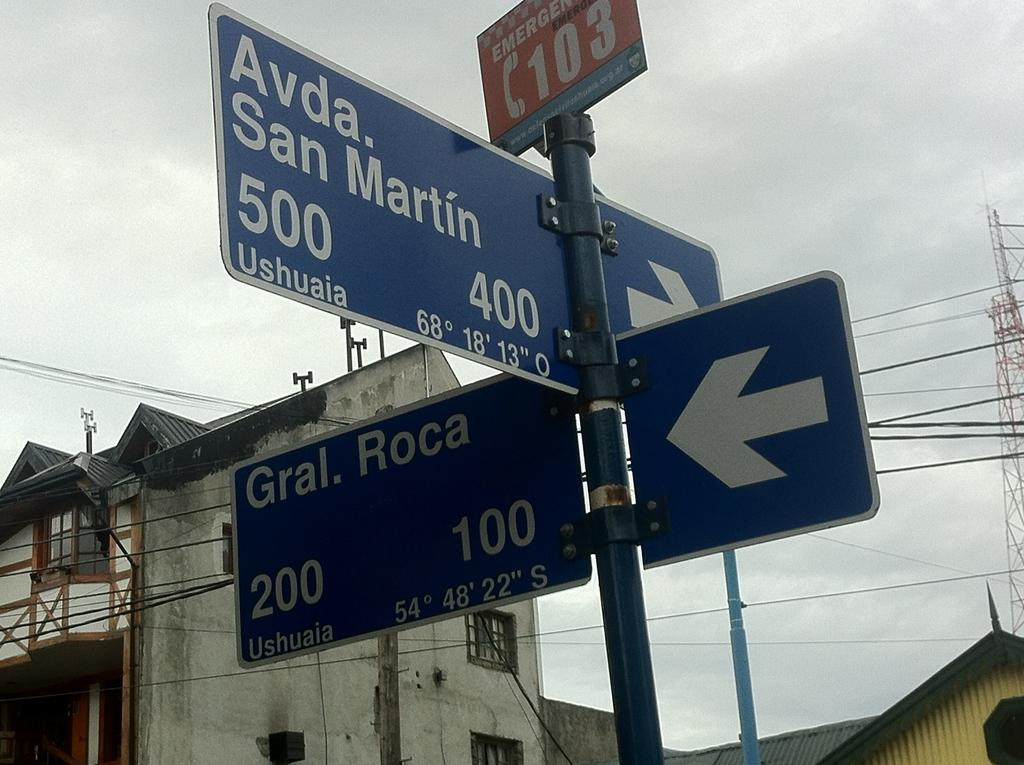<image>
Render a clear and concise summary of the photo. Multiple road signs with directions to two different streets 